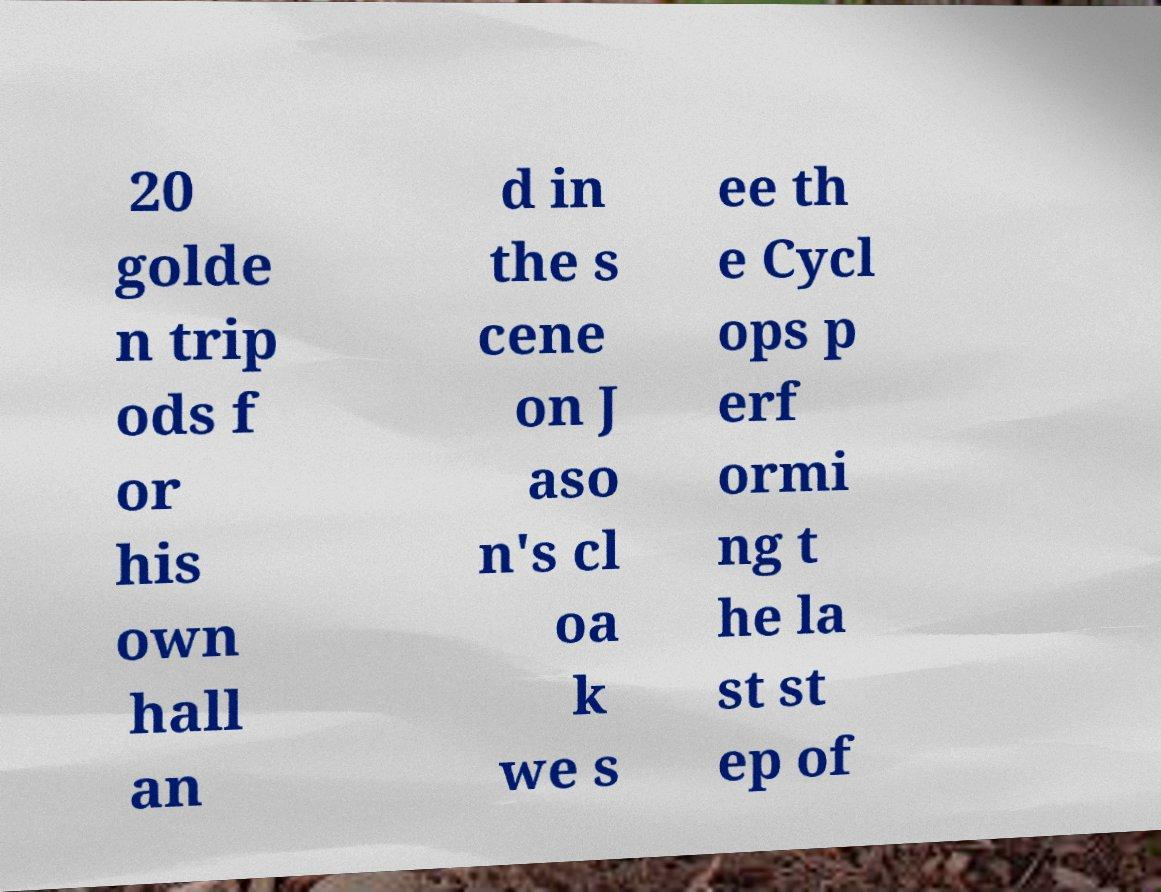Could you assist in decoding the text presented in this image and type it out clearly? 20 golde n trip ods f or his own hall an d in the s cene on J aso n's cl oa k we s ee th e Cycl ops p erf ormi ng t he la st st ep of 